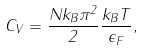<formula> <loc_0><loc_0><loc_500><loc_500>C _ { V } = \frac { N k _ { B } \pi ^ { 2 } } { 2 } \frac { k _ { B } T } { \epsilon _ { F } } ,</formula> 